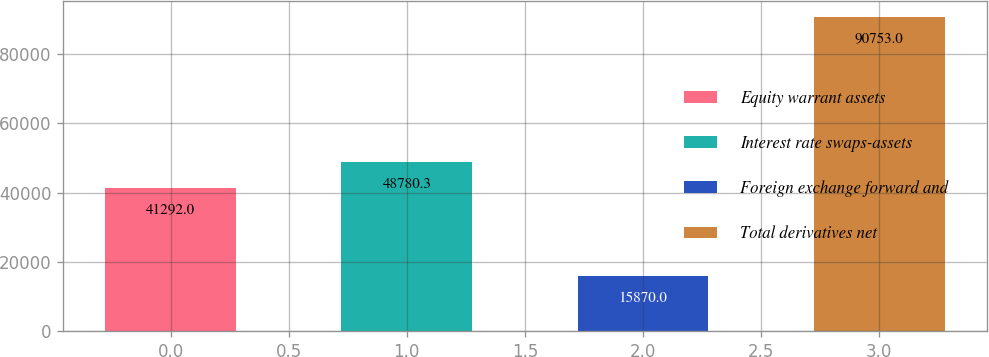Convert chart. <chart><loc_0><loc_0><loc_500><loc_500><bar_chart><fcel>Equity warrant assets<fcel>Interest rate swaps-assets<fcel>Foreign exchange forward and<fcel>Total derivatives net<nl><fcel>41292<fcel>48780.3<fcel>15870<fcel>90753<nl></chart> 